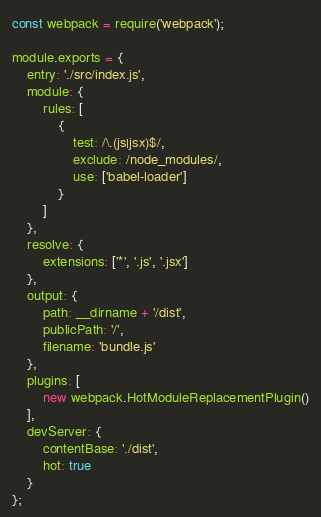Convert code to text. <code><loc_0><loc_0><loc_500><loc_500><_JavaScript_>const webpack = require('webpack');

module.exports = {
	entry: './src/index.js',
	module: {
		rules: [
			{
				test: /\.(js|jsx)$/,
				exclude: /node_modules/,
				use: ['babel-loader']
			}
		]
	},
	resolve: {
		extensions: ['*', '.js', '.jsx']
	},
	output: {
		path: __dirname + '/dist',
		publicPath: '/',
		filename: 'bundle.js'
	},
	plugins: [
		new webpack.HotModuleReplacementPlugin()
	],
	devServer: {
		contentBase: './dist',
		hot: true
	}
};</code> 